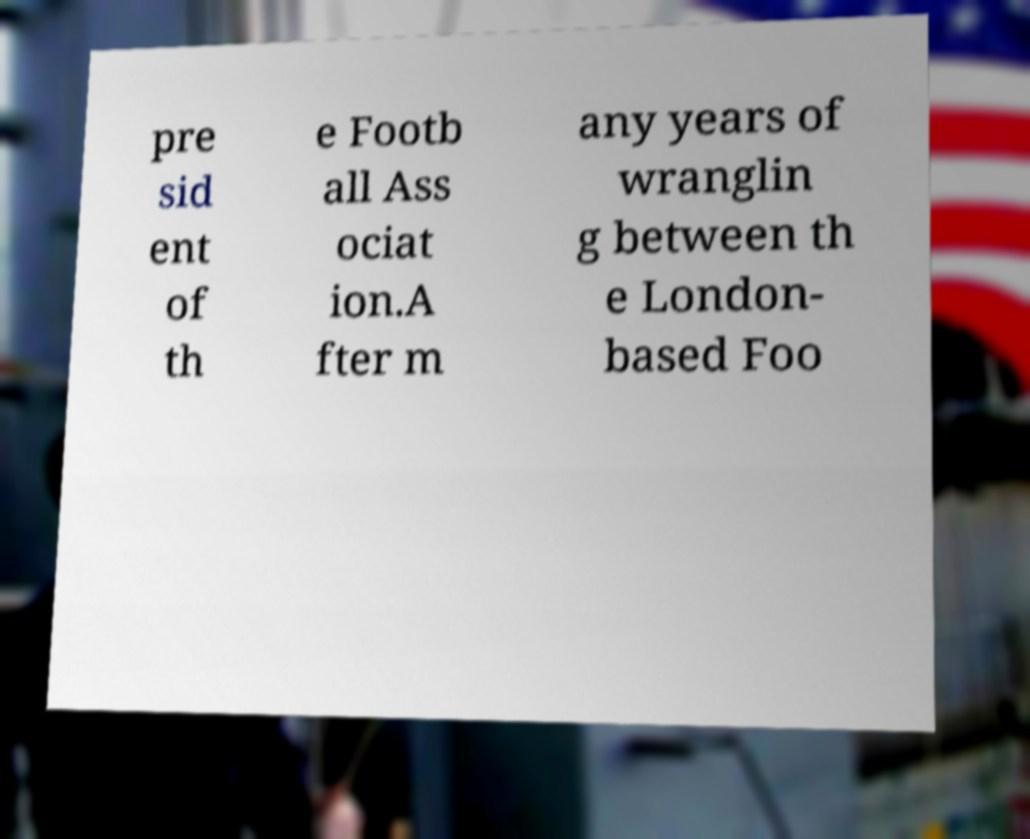Can you accurately transcribe the text from the provided image for me? pre sid ent of th e Footb all Ass ociat ion.A fter m any years of wranglin g between th e London- based Foo 